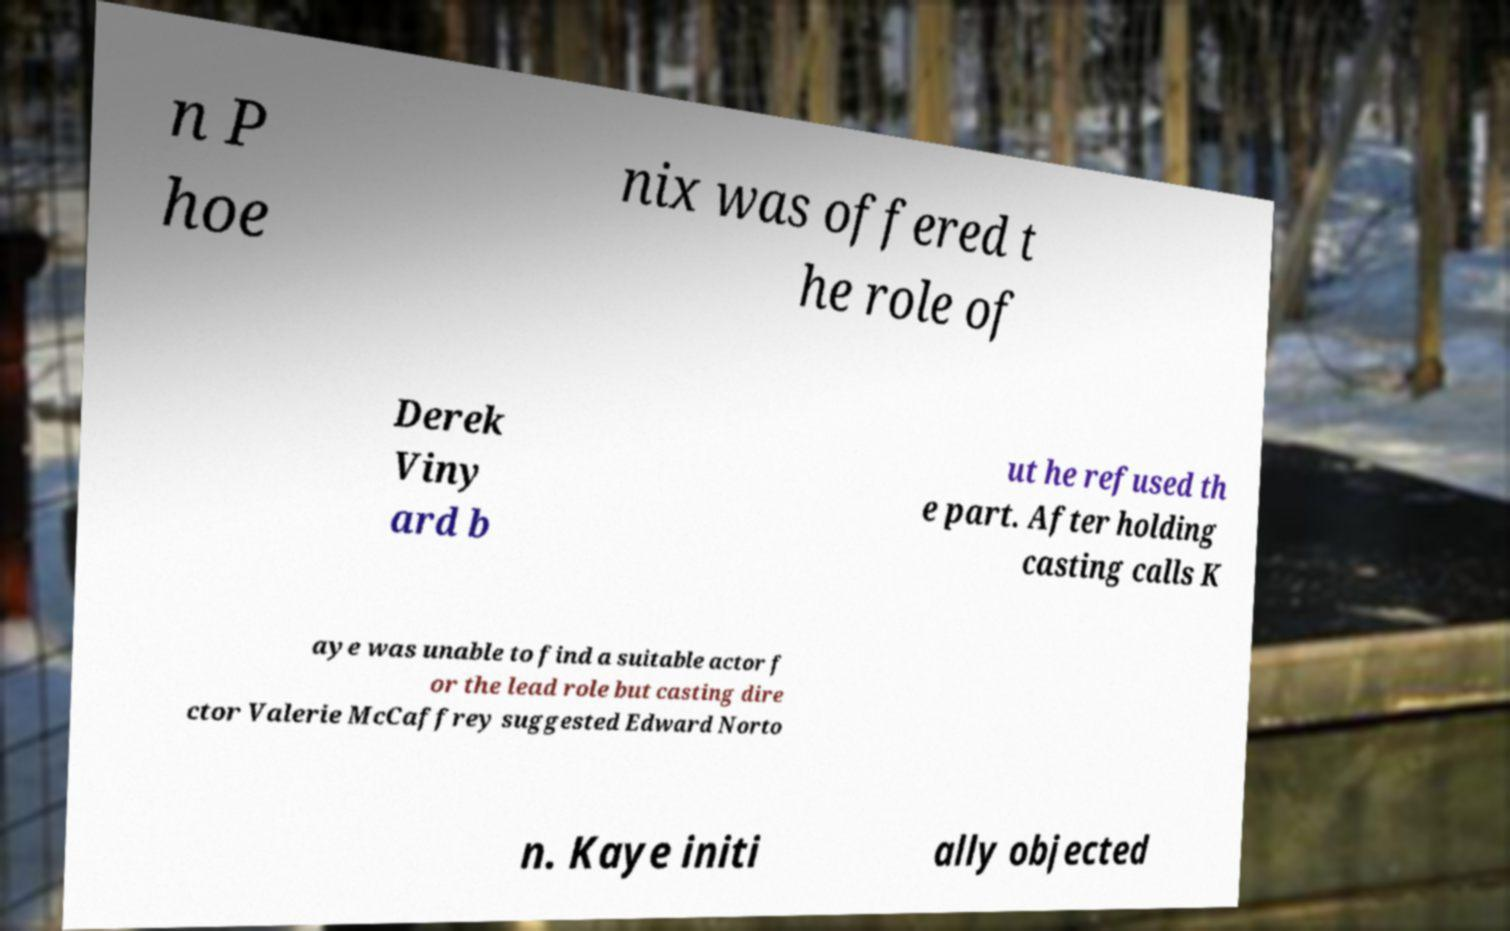Please read and relay the text visible in this image. What does it say? n P hoe nix was offered t he role of Derek Viny ard b ut he refused th e part. After holding casting calls K aye was unable to find a suitable actor f or the lead role but casting dire ctor Valerie McCaffrey suggested Edward Norto n. Kaye initi ally objected 